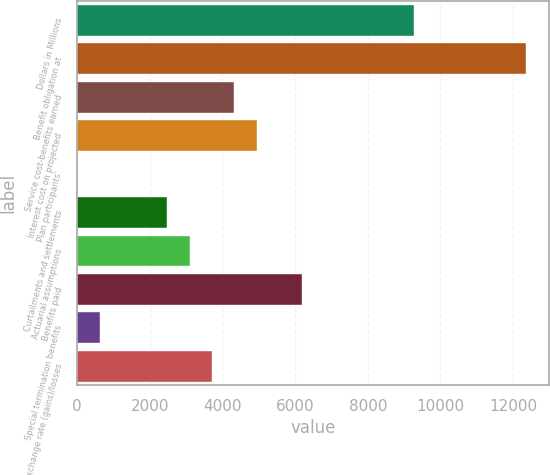Convert chart to OTSL. <chart><loc_0><loc_0><loc_500><loc_500><bar_chart><fcel>Dollars in Millions<fcel>Benefit obligation at<fcel>Service cost-benefits earned<fcel>Interest cost on projected<fcel>Plan participants'<fcel>Curtailments and settlements<fcel>Actuarial assumptions<fcel>Benefits paid<fcel>Special termination benefits<fcel>Exchange rate (gains)/losses<nl><fcel>9273.5<fcel>12363<fcel>4330.3<fcel>4948.2<fcel>5<fcel>2476.6<fcel>3094.5<fcel>6184<fcel>622.9<fcel>3712.4<nl></chart> 